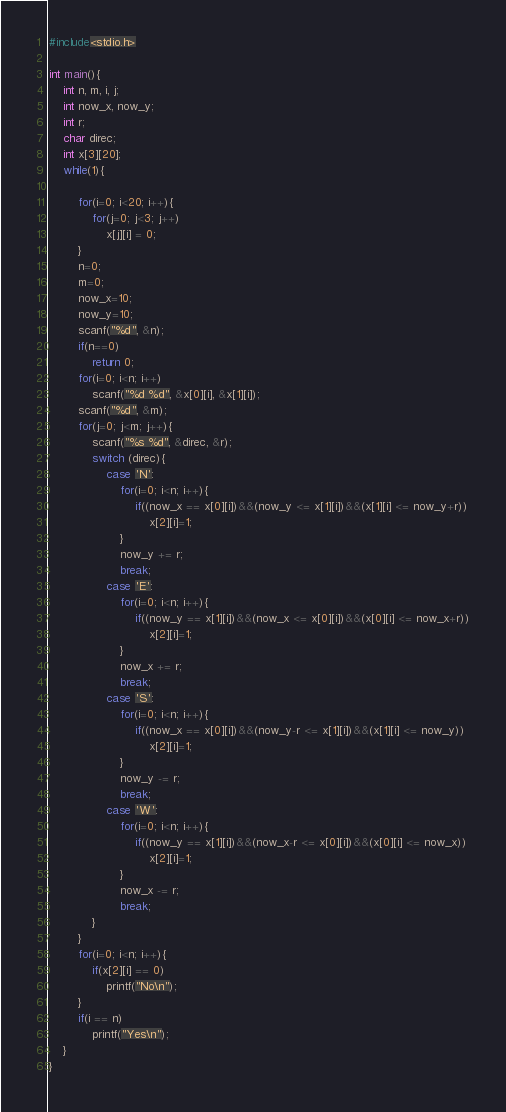Convert code to text. <code><loc_0><loc_0><loc_500><loc_500><_C_>#include<stdio.h>

int main(){
	int n, m, i, j;
	int now_x, now_y;
	int r;
	char direc;
	int x[3][20];
	while(1){

		for(i=0; i<20; i++){
			for(j=0; j<3; j++)
				x[j][i] = 0;
		}
		n=0;
		m=0;
		now_x=10;
		now_y=10;
		scanf("%d", &n);
		if(n==0)
			return 0;
		for(i=0; i<n; i++)
			scanf("%d %d", &x[0][i], &x[1][i]);
		scanf("%d", &m);
		for(j=0; j<m; j++){
			scanf("%s %d", &direc, &r);
			switch (direc){
				case 'N':
					for(i=0; i<n; i++){
						if((now_x == x[0][i])&&(now_y <= x[1][i])&&(x[1][i] <= now_y+r))
							x[2][i]=1;
					}
					now_y += r;
					break;
				case 'E':
					for(i=0; i<n; i++){
						if((now_y == x[1][i])&&(now_x <= x[0][i])&&(x[0][i] <= now_x+r))
							x[2][i]=1;
					}
					now_x += r;
					break;
				case 'S':
					for(i=0; i<n; i++){
						if((now_x == x[0][i])&&(now_y-r <= x[1][i])&&(x[1][i] <= now_y))
							x[2][i]=1;
					}
					now_y -= r;
					break;
				case 'W':
					for(i=0; i<n; i++){
						if((now_y == x[1][i])&&(now_x-r <= x[0][i])&&(x[0][i] <= now_x))
							x[2][i]=1;
					}
					now_x -= r;
					break;
			}
		}
		for(i=0; i<n; i++){
			if(x[2][i] == 0)
				printf("No\n");
		}
		if(i == n)
			printf("Yes\n");
	}
}</code> 